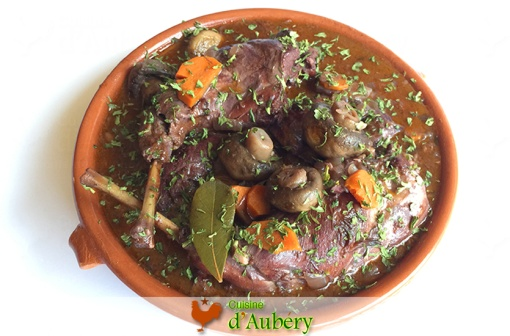Imagine you are a critic at a prestigious gourmet magazine. Write a highly detailed review of this dish. In the heart of the culinary arts, **Coq au Vin** stands as an epitome of French gastronomy, bringing a radiant symphony of flavors and tradition to the table. Presented in an elegant terracotta dish, this masterpiece showcases tender, succulent chicken pieces that have been meticulously cooked to perfection. Each bite unveils layers of savory depth accentuated by the rich, velvety sauce that envelops the dish. The sauce, a robust reduction of fine wine, mingles harmoniously with the earthy undertones of mushrooms and the sweet accents of carrots. Garnished thoughtfully with freshly chopped herbs, the dish is both visually and gastronomically appealing, offering a balanced interplay of textures and flavors. The crowning touch - a single, aromatic bay leaf - hints at the intricate layer of seasoning that permeates each component. This **Coq au Vin** is not merely food; it is an experience, a journey through time and tradition, and a testament to the chef's profound respect for the art of cooking. 